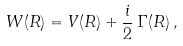<formula> <loc_0><loc_0><loc_500><loc_500>W ( R ) = V ( R ) + \frac { i } { 2 } \, \Gamma ( R ) \, ,</formula> 